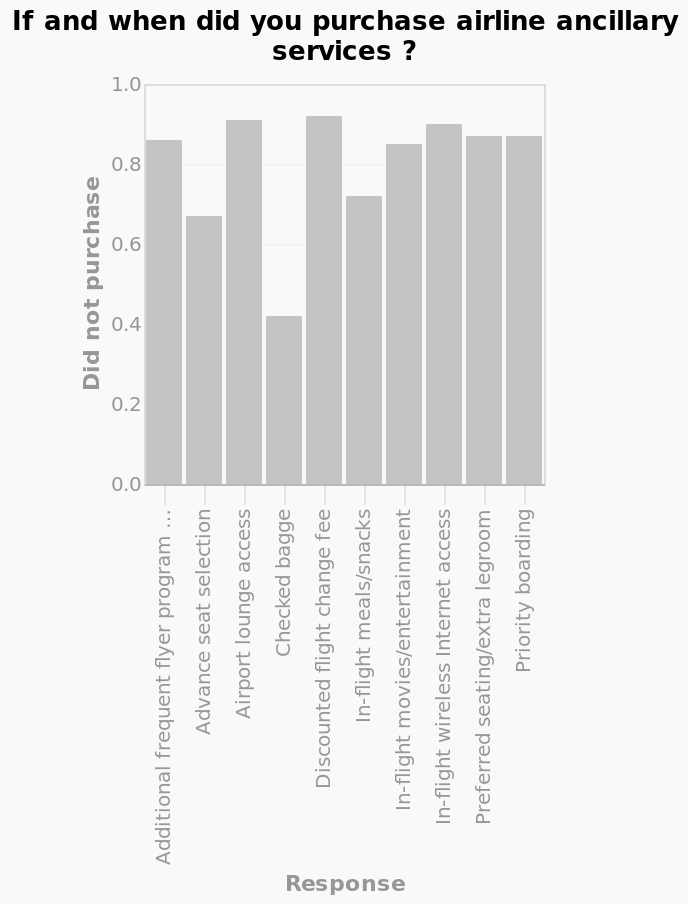<image>
What does the y-axis measure in the bar chart?  The y-axis measures the number of respondents who did not purchase airline ancillary services. Describe the following image in detail If and when did you purchase airline ancillary services ? is a bar chart. The y-axis measures Did not purchase while the x-axis measures Response. Which item had the lowest number of purchases?  The discounted flight fee had the lowest number of purchases. What did the majority of people choose to buy? The majority of people chose to buy the checked bag. 